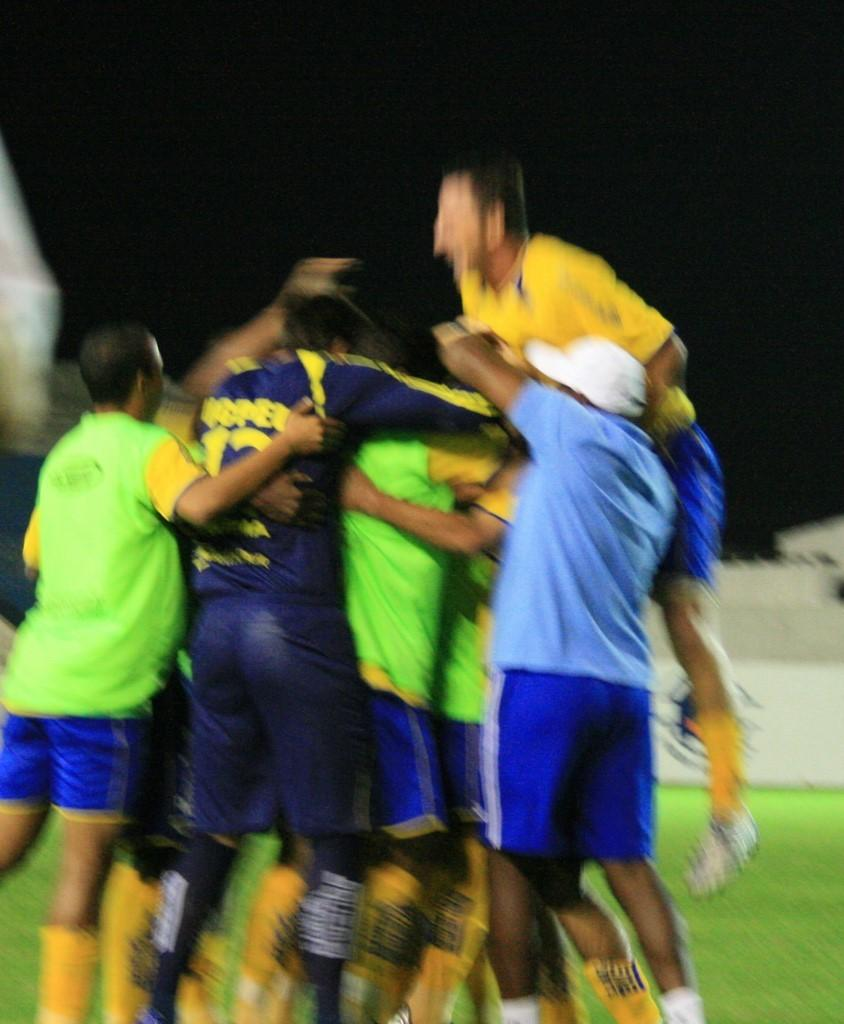How many people are in the image? There is a group of persons in the image. What can be observed about the attire of the persons in the image? The persons are wearing different color dresses. What type of surface is the group standing on? The group is standing on a greenery ground. What else can be seen in the background of the image? There are other objects in the background of the image. What type of office furniture can be seen in the image? There is no office furniture present in the image; it features a group of persons standing on a greenery ground. 